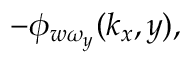Convert formula to latex. <formula><loc_0><loc_0><loc_500><loc_500>- \phi _ { w \omega _ { y } } ( k _ { x } , y ) ,</formula> 